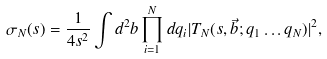Convert formula to latex. <formula><loc_0><loc_0><loc_500><loc_500>\sigma _ { N } ( s ) = \frac { 1 } { 4 s ^ { 2 } } \int d ^ { 2 } b \prod _ { i = 1 } ^ { N } d q _ { i } | T _ { N } ( s , \vec { b } ; q _ { 1 } \dots q _ { N } ) | ^ { 2 } ,</formula> 